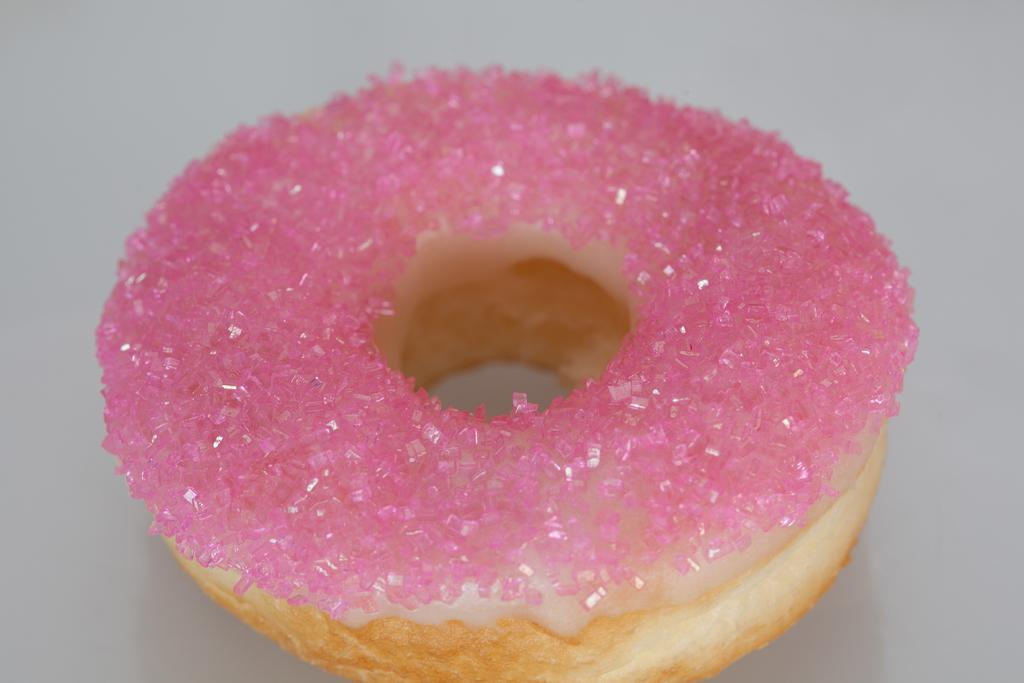What type of food is present in the image? There is a donut in the image. What type of whip can be seen cracking in the image? There is no whip present in the image, and therefore no such activity can be observed. 